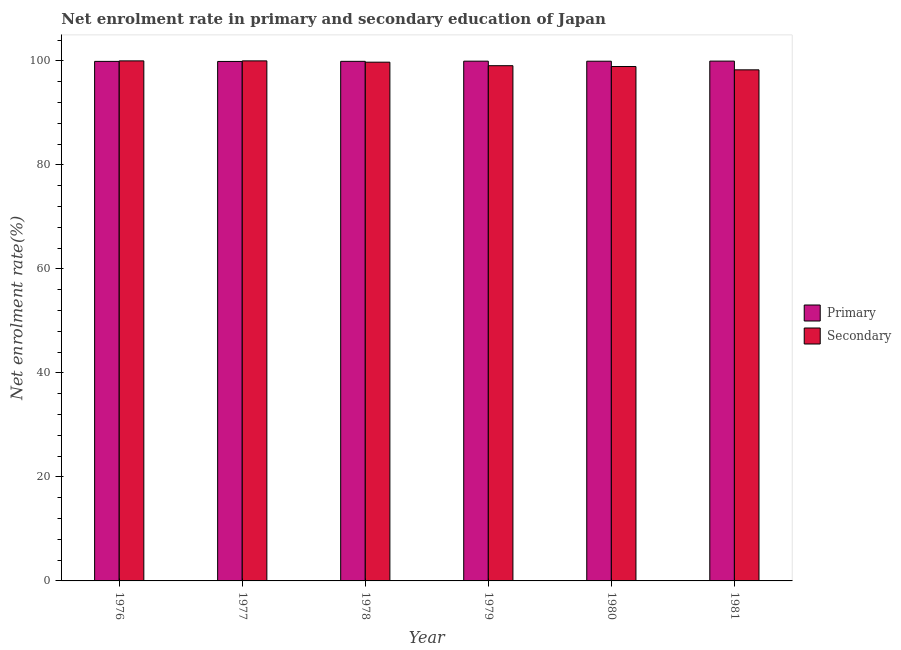How many groups of bars are there?
Keep it short and to the point. 6. Are the number of bars per tick equal to the number of legend labels?
Your response must be concise. Yes. How many bars are there on the 1st tick from the right?
Keep it short and to the point. 2. What is the enrollment rate in primary education in 1976?
Your answer should be compact. 99.9. Across all years, what is the maximum enrollment rate in primary education?
Keep it short and to the point. 99.96. Across all years, what is the minimum enrollment rate in primary education?
Provide a succinct answer. 99.89. In which year was the enrollment rate in primary education maximum?
Ensure brevity in your answer.  1981. In which year was the enrollment rate in primary education minimum?
Keep it short and to the point. 1977. What is the total enrollment rate in primary education in the graph?
Offer a very short reply. 599.54. What is the difference between the enrollment rate in primary education in 1976 and that in 1980?
Your answer should be very brief. -0.03. What is the difference between the enrollment rate in secondary education in 1979 and the enrollment rate in primary education in 1980?
Keep it short and to the point. 0.16. What is the average enrollment rate in primary education per year?
Provide a succinct answer. 99.92. In the year 1978, what is the difference between the enrollment rate in primary education and enrollment rate in secondary education?
Keep it short and to the point. 0. In how many years, is the enrollment rate in secondary education greater than 36 %?
Offer a very short reply. 6. What is the ratio of the enrollment rate in secondary education in 1979 to that in 1980?
Make the answer very short. 1. Is the enrollment rate in secondary education in 1979 less than that in 1981?
Your answer should be very brief. No. Is the difference between the enrollment rate in primary education in 1979 and 1981 greater than the difference between the enrollment rate in secondary education in 1979 and 1981?
Provide a succinct answer. No. What is the difference between the highest and the second highest enrollment rate in primary education?
Provide a succinct answer. 0.01. What is the difference between the highest and the lowest enrollment rate in primary education?
Provide a succinct answer. 0.07. In how many years, is the enrollment rate in secondary education greater than the average enrollment rate in secondary education taken over all years?
Give a very brief answer. 3. What does the 2nd bar from the left in 1976 represents?
Ensure brevity in your answer.  Secondary. What does the 2nd bar from the right in 1977 represents?
Keep it short and to the point. Primary. Are the values on the major ticks of Y-axis written in scientific E-notation?
Ensure brevity in your answer.  No. Where does the legend appear in the graph?
Provide a short and direct response. Center right. How many legend labels are there?
Keep it short and to the point. 2. What is the title of the graph?
Give a very brief answer. Net enrolment rate in primary and secondary education of Japan. What is the label or title of the X-axis?
Give a very brief answer. Year. What is the label or title of the Y-axis?
Keep it short and to the point. Net enrolment rate(%). What is the Net enrolment rate(%) in Primary in 1976?
Offer a terse response. 99.9. What is the Net enrolment rate(%) of Primary in 1977?
Give a very brief answer. 99.89. What is the Net enrolment rate(%) of Primary in 1978?
Offer a terse response. 99.91. What is the Net enrolment rate(%) of Secondary in 1978?
Your answer should be compact. 99.75. What is the Net enrolment rate(%) in Primary in 1979?
Provide a short and direct response. 99.95. What is the Net enrolment rate(%) in Secondary in 1979?
Offer a very short reply. 99.07. What is the Net enrolment rate(%) of Primary in 1980?
Give a very brief answer. 99.94. What is the Net enrolment rate(%) in Secondary in 1980?
Your response must be concise. 98.92. What is the Net enrolment rate(%) of Primary in 1981?
Your answer should be very brief. 99.96. What is the Net enrolment rate(%) of Secondary in 1981?
Make the answer very short. 98.28. Across all years, what is the maximum Net enrolment rate(%) in Primary?
Your answer should be very brief. 99.96. Across all years, what is the minimum Net enrolment rate(%) in Primary?
Provide a short and direct response. 99.89. Across all years, what is the minimum Net enrolment rate(%) in Secondary?
Your response must be concise. 98.28. What is the total Net enrolment rate(%) of Primary in the graph?
Ensure brevity in your answer.  599.54. What is the total Net enrolment rate(%) of Secondary in the graph?
Offer a very short reply. 596.01. What is the difference between the Net enrolment rate(%) in Primary in 1976 and that in 1977?
Your answer should be very brief. 0.01. What is the difference between the Net enrolment rate(%) of Primary in 1976 and that in 1978?
Provide a succinct answer. -0.01. What is the difference between the Net enrolment rate(%) in Secondary in 1976 and that in 1978?
Offer a very short reply. 0.25. What is the difference between the Net enrolment rate(%) of Primary in 1976 and that in 1979?
Your answer should be very brief. -0.04. What is the difference between the Net enrolment rate(%) in Secondary in 1976 and that in 1979?
Provide a succinct answer. 0.93. What is the difference between the Net enrolment rate(%) of Primary in 1976 and that in 1980?
Your response must be concise. -0.03. What is the difference between the Net enrolment rate(%) of Secondary in 1976 and that in 1980?
Offer a very short reply. 1.08. What is the difference between the Net enrolment rate(%) in Primary in 1976 and that in 1981?
Offer a very short reply. -0.05. What is the difference between the Net enrolment rate(%) in Secondary in 1976 and that in 1981?
Offer a very short reply. 1.72. What is the difference between the Net enrolment rate(%) in Primary in 1977 and that in 1978?
Provide a short and direct response. -0.02. What is the difference between the Net enrolment rate(%) of Secondary in 1977 and that in 1978?
Offer a very short reply. 0.25. What is the difference between the Net enrolment rate(%) of Primary in 1977 and that in 1979?
Ensure brevity in your answer.  -0.06. What is the difference between the Net enrolment rate(%) of Secondary in 1977 and that in 1979?
Give a very brief answer. 0.93. What is the difference between the Net enrolment rate(%) of Primary in 1977 and that in 1980?
Provide a short and direct response. -0.04. What is the difference between the Net enrolment rate(%) of Secondary in 1977 and that in 1980?
Make the answer very short. 1.08. What is the difference between the Net enrolment rate(%) of Primary in 1977 and that in 1981?
Make the answer very short. -0.07. What is the difference between the Net enrolment rate(%) in Secondary in 1977 and that in 1981?
Your answer should be compact. 1.72. What is the difference between the Net enrolment rate(%) of Primary in 1978 and that in 1979?
Give a very brief answer. -0.03. What is the difference between the Net enrolment rate(%) in Secondary in 1978 and that in 1979?
Give a very brief answer. 0.68. What is the difference between the Net enrolment rate(%) of Primary in 1978 and that in 1980?
Give a very brief answer. -0.02. What is the difference between the Net enrolment rate(%) of Secondary in 1978 and that in 1980?
Your answer should be compact. 0.83. What is the difference between the Net enrolment rate(%) in Primary in 1978 and that in 1981?
Make the answer very short. -0.04. What is the difference between the Net enrolment rate(%) of Secondary in 1978 and that in 1981?
Offer a terse response. 1.47. What is the difference between the Net enrolment rate(%) of Primary in 1979 and that in 1980?
Ensure brevity in your answer.  0.01. What is the difference between the Net enrolment rate(%) in Secondary in 1979 and that in 1980?
Offer a terse response. 0.16. What is the difference between the Net enrolment rate(%) in Primary in 1979 and that in 1981?
Provide a succinct answer. -0.01. What is the difference between the Net enrolment rate(%) of Secondary in 1979 and that in 1981?
Your answer should be compact. 0.8. What is the difference between the Net enrolment rate(%) in Primary in 1980 and that in 1981?
Your answer should be very brief. -0.02. What is the difference between the Net enrolment rate(%) in Secondary in 1980 and that in 1981?
Give a very brief answer. 0.64. What is the difference between the Net enrolment rate(%) in Primary in 1976 and the Net enrolment rate(%) in Secondary in 1977?
Your answer should be compact. -0.1. What is the difference between the Net enrolment rate(%) in Primary in 1976 and the Net enrolment rate(%) in Secondary in 1978?
Keep it short and to the point. 0.15. What is the difference between the Net enrolment rate(%) of Primary in 1976 and the Net enrolment rate(%) of Secondary in 1979?
Your response must be concise. 0.83. What is the difference between the Net enrolment rate(%) in Primary in 1976 and the Net enrolment rate(%) in Secondary in 1981?
Your response must be concise. 1.63. What is the difference between the Net enrolment rate(%) in Primary in 1977 and the Net enrolment rate(%) in Secondary in 1978?
Provide a succinct answer. 0.14. What is the difference between the Net enrolment rate(%) in Primary in 1977 and the Net enrolment rate(%) in Secondary in 1979?
Give a very brief answer. 0.82. What is the difference between the Net enrolment rate(%) of Primary in 1977 and the Net enrolment rate(%) of Secondary in 1980?
Your response must be concise. 0.98. What is the difference between the Net enrolment rate(%) of Primary in 1977 and the Net enrolment rate(%) of Secondary in 1981?
Offer a terse response. 1.61. What is the difference between the Net enrolment rate(%) of Primary in 1978 and the Net enrolment rate(%) of Secondary in 1979?
Give a very brief answer. 0.84. What is the difference between the Net enrolment rate(%) of Primary in 1978 and the Net enrolment rate(%) of Secondary in 1981?
Provide a short and direct response. 1.64. What is the difference between the Net enrolment rate(%) of Primary in 1979 and the Net enrolment rate(%) of Secondary in 1980?
Ensure brevity in your answer.  1.03. What is the difference between the Net enrolment rate(%) in Primary in 1979 and the Net enrolment rate(%) in Secondary in 1981?
Offer a terse response. 1.67. What is the difference between the Net enrolment rate(%) in Primary in 1980 and the Net enrolment rate(%) in Secondary in 1981?
Offer a very short reply. 1.66. What is the average Net enrolment rate(%) of Primary per year?
Ensure brevity in your answer.  99.92. What is the average Net enrolment rate(%) of Secondary per year?
Keep it short and to the point. 99.34. In the year 1976, what is the difference between the Net enrolment rate(%) of Primary and Net enrolment rate(%) of Secondary?
Provide a short and direct response. -0.1. In the year 1977, what is the difference between the Net enrolment rate(%) in Primary and Net enrolment rate(%) in Secondary?
Ensure brevity in your answer.  -0.11. In the year 1978, what is the difference between the Net enrolment rate(%) of Primary and Net enrolment rate(%) of Secondary?
Keep it short and to the point. 0.16. In the year 1979, what is the difference between the Net enrolment rate(%) in Primary and Net enrolment rate(%) in Secondary?
Offer a very short reply. 0.87. In the year 1980, what is the difference between the Net enrolment rate(%) in Primary and Net enrolment rate(%) in Secondary?
Offer a terse response. 1.02. In the year 1981, what is the difference between the Net enrolment rate(%) of Primary and Net enrolment rate(%) of Secondary?
Provide a succinct answer. 1.68. What is the ratio of the Net enrolment rate(%) in Primary in 1976 to that in 1977?
Provide a succinct answer. 1. What is the ratio of the Net enrolment rate(%) of Primary in 1976 to that in 1978?
Keep it short and to the point. 1. What is the ratio of the Net enrolment rate(%) in Secondary in 1976 to that in 1978?
Offer a terse response. 1. What is the ratio of the Net enrolment rate(%) of Primary in 1976 to that in 1979?
Offer a very short reply. 1. What is the ratio of the Net enrolment rate(%) of Secondary in 1976 to that in 1979?
Offer a terse response. 1.01. What is the ratio of the Net enrolment rate(%) of Secondary in 1976 to that in 1980?
Your response must be concise. 1.01. What is the ratio of the Net enrolment rate(%) in Primary in 1976 to that in 1981?
Your answer should be compact. 1. What is the ratio of the Net enrolment rate(%) in Secondary in 1976 to that in 1981?
Your answer should be compact. 1.02. What is the ratio of the Net enrolment rate(%) in Primary in 1977 to that in 1978?
Your response must be concise. 1. What is the ratio of the Net enrolment rate(%) of Secondary in 1977 to that in 1979?
Provide a succinct answer. 1.01. What is the ratio of the Net enrolment rate(%) of Secondary in 1977 to that in 1980?
Give a very brief answer. 1.01. What is the ratio of the Net enrolment rate(%) in Secondary in 1977 to that in 1981?
Offer a terse response. 1.02. What is the ratio of the Net enrolment rate(%) of Secondary in 1978 to that in 1979?
Give a very brief answer. 1.01. What is the ratio of the Net enrolment rate(%) in Primary in 1978 to that in 1980?
Offer a terse response. 1. What is the ratio of the Net enrolment rate(%) of Secondary in 1978 to that in 1980?
Make the answer very short. 1.01. What is the ratio of the Net enrolment rate(%) of Primary in 1978 to that in 1981?
Your response must be concise. 1. What is the ratio of the Net enrolment rate(%) in Secondary in 1978 to that in 1981?
Give a very brief answer. 1.01. What is the ratio of the Net enrolment rate(%) of Primary in 1979 to that in 1981?
Offer a terse response. 1. What is the ratio of the Net enrolment rate(%) in Primary in 1980 to that in 1981?
Offer a very short reply. 1. What is the ratio of the Net enrolment rate(%) of Secondary in 1980 to that in 1981?
Provide a succinct answer. 1.01. What is the difference between the highest and the second highest Net enrolment rate(%) in Primary?
Give a very brief answer. 0.01. What is the difference between the highest and the second highest Net enrolment rate(%) in Secondary?
Offer a terse response. 0. What is the difference between the highest and the lowest Net enrolment rate(%) in Primary?
Your answer should be compact. 0.07. What is the difference between the highest and the lowest Net enrolment rate(%) of Secondary?
Offer a terse response. 1.72. 